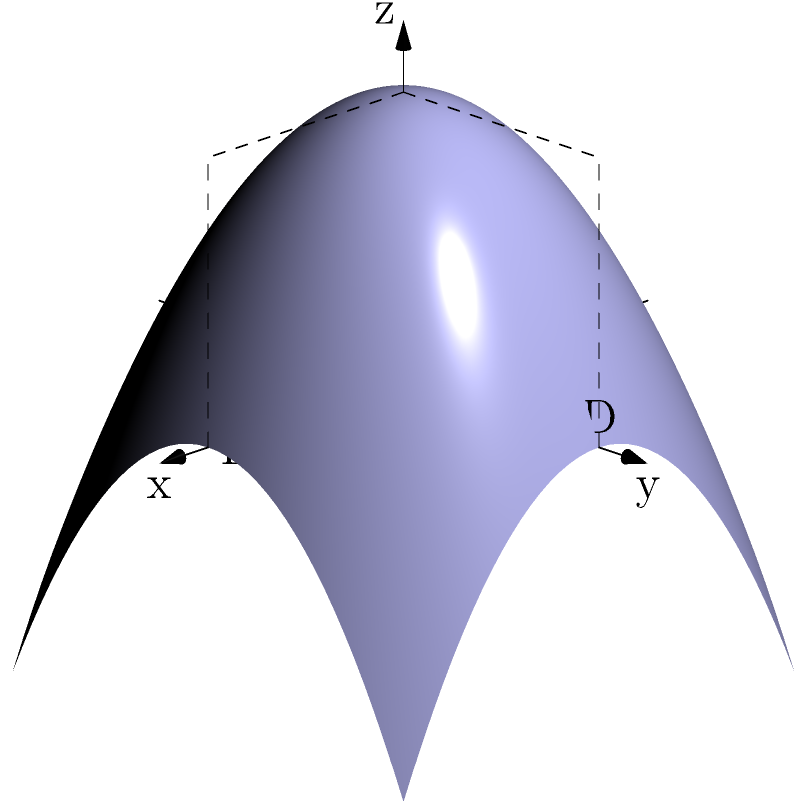The image shows a 3D representation of an atmospheric pressure system. Which of the following cross-sections would correctly represent the pressure distribution along the line AB?

1) A concave upward curve
2) A straight line
3) A concave downward curve
4) A sinusoidal curve To determine the correct cross-section of the 3D atmospheric pressure system along the line AB, we need to analyze the shape of the surface and how it intersects with the vertical plane passing through AB:

1. The surface represents an atmospheric pressure system, where height corresponds to pressure (higher elevation means higher pressure).

2. The shape of the surface is a paraboloid, which is described by the equation $z = f(x,y) = 4 - x^2 - y^2$.

3. The line AB runs along the x-axis from x = -2 to x = 2, with y = 0.

4. To find the cross-section along AB, we need to consider the function $z = f(x,0) = 4 - x^2$.

5. This equation represents a parabola opening downwards, with its vertex at (0,4).

6. When plotted on the xz-plane (which is the vertical plane containing AB), this parabola would appear as a concave downward curve.

Therefore, the correct cross-section representing the pressure distribution along the line AB is a concave downward curve.
Answer: A concave downward curve 